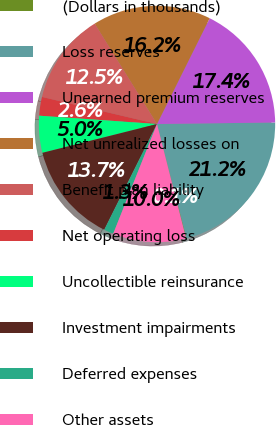<chart> <loc_0><loc_0><loc_500><loc_500><pie_chart><fcel>(Dollars in thousands)<fcel>Loss reserves<fcel>Unearned premium reserves<fcel>Net unrealized losses on<fcel>Benefit plan liability<fcel>Net operating loss<fcel>Uncollectible reinsurance<fcel>Investment impairments<fcel>Deferred expenses<fcel>Other assets<nl><fcel>0.08%<fcel>21.17%<fcel>17.44%<fcel>16.2%<fcel>12.48%<fcel>2.56%<fcel>5.04%<fcel>13.72%<fcel>1.32%<fcel>10.0%<nl></chart> 